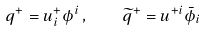Convert formula to latex. <formula><loc_0><loc_0><loc_500><loc_500>q ^ { + } = u ^ { + } _ { i } \phi ^ { i } \, , \quad \widetilde { q } ^ { + } = u ^ { + i } \bar { \phi } _ { i }</formula> 